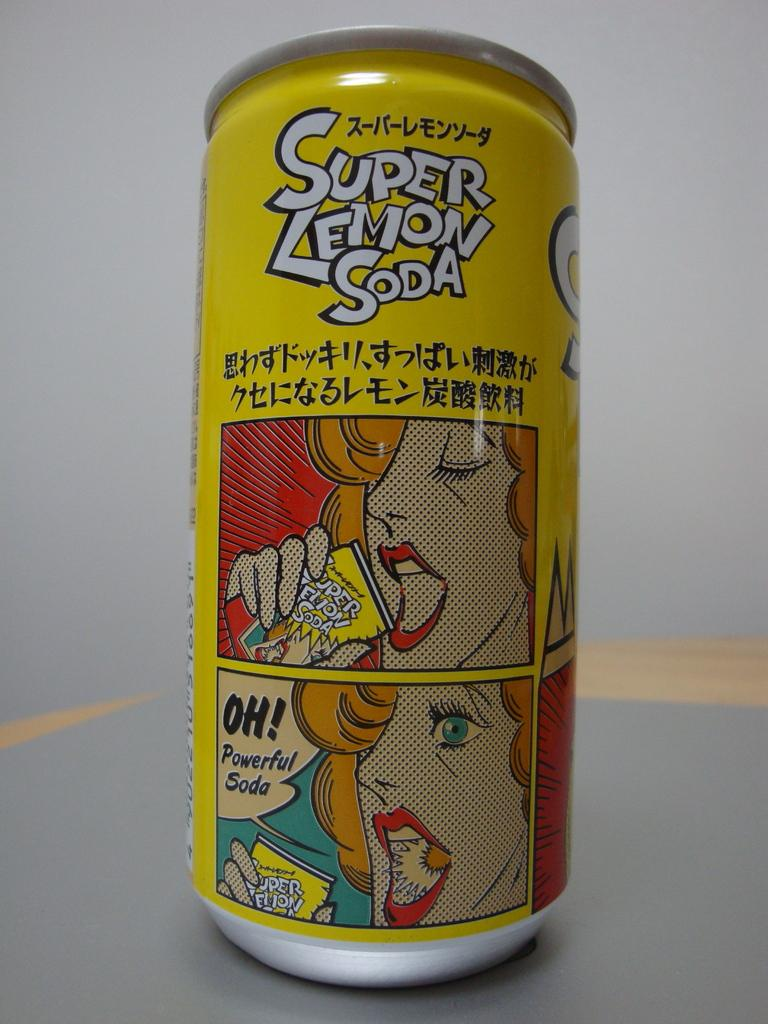<image>
Provide a brief description of the given image. A can of super lemon soda features pop art on the label. 